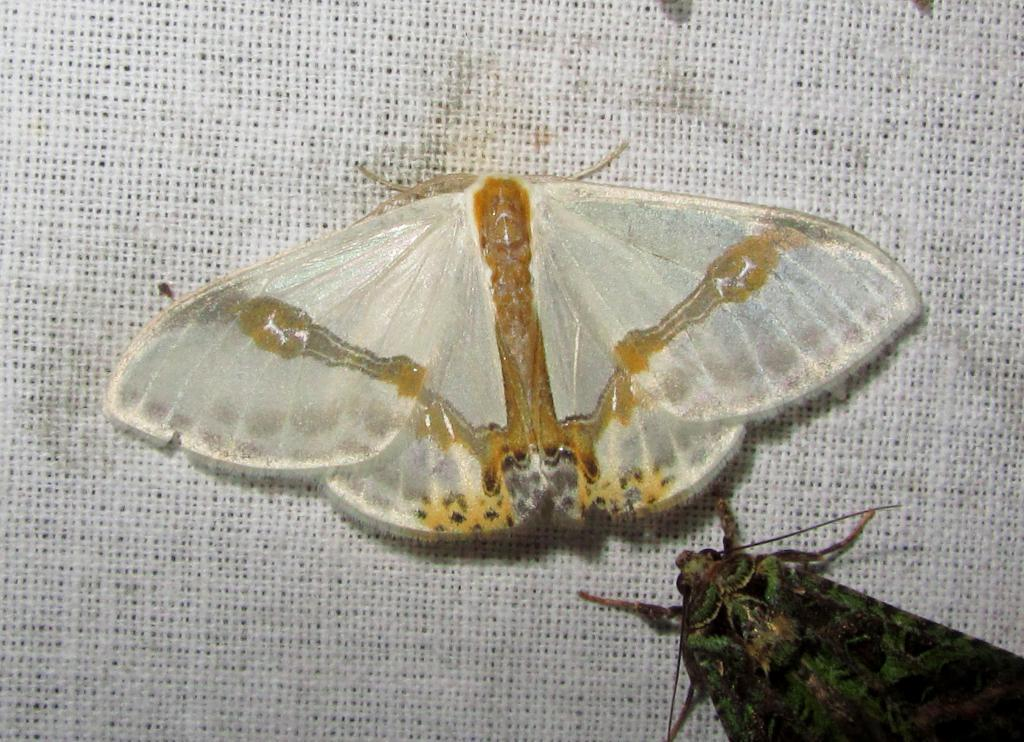How many butterflies are present in the image? There are two butterflies in the image. What is the color of the surface on which the butterflies are resting? The butterflies are on a white surface. What type of poison is the woman holding in the image? There is no woman or poison present in the image; it features two butterflies on a white surface. 